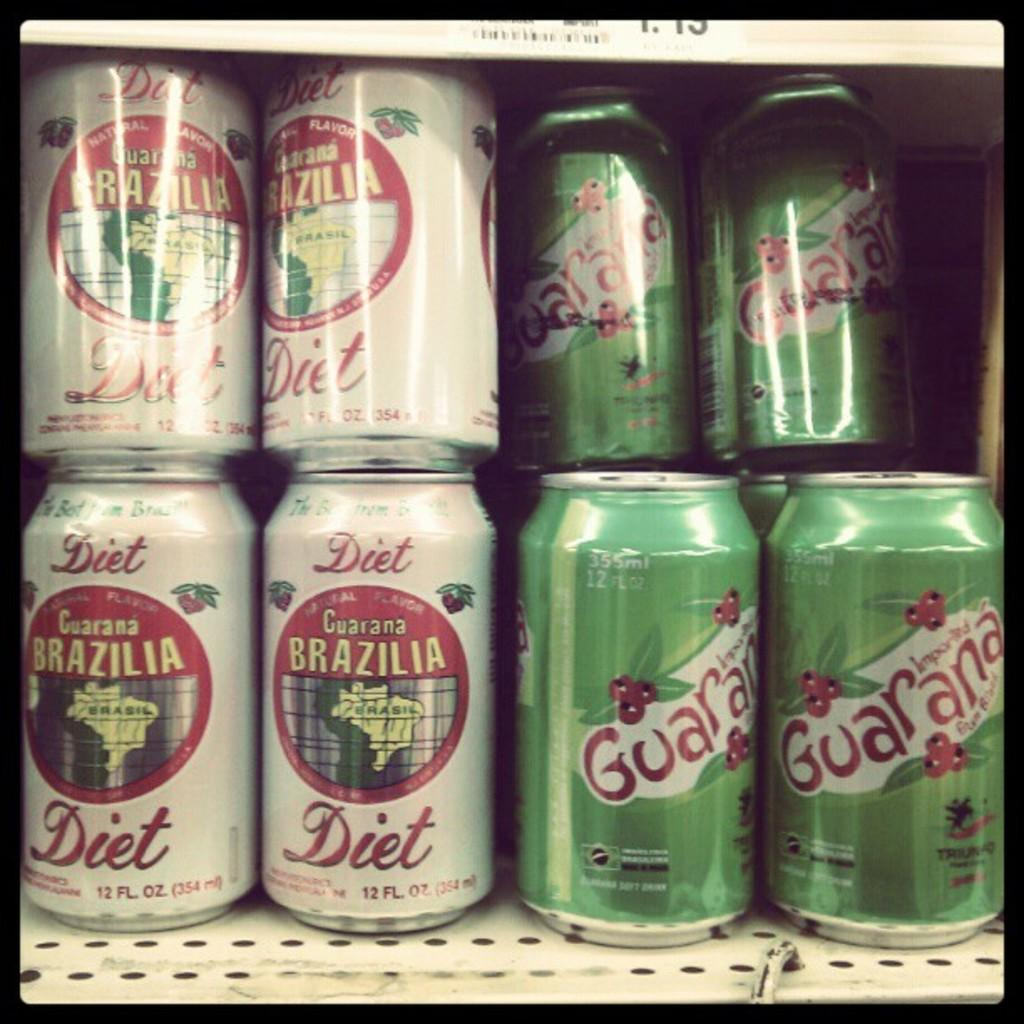<image>
Summarize the visual content of the image. Green and white cans of Brazilia Diet Cola and Guarana. 